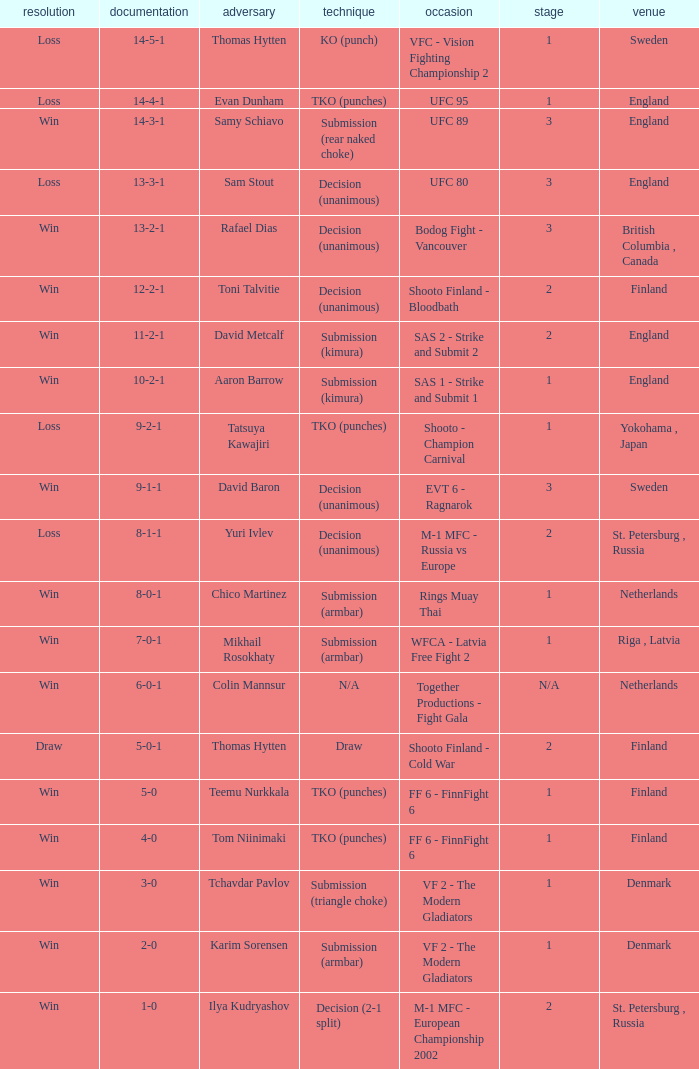What is the round in Finland with a draw for method? 2.0. 